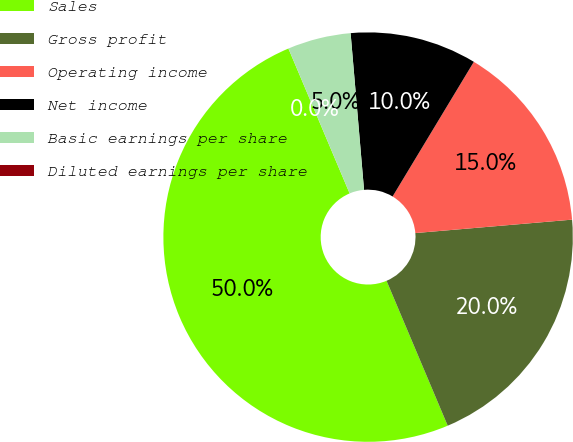<chart> <loc_0><loc_0><loc_500><loc_500><pie_chart><fcel>Sales<fcel>Gross profit<fcel>Operating income<fcel>Net income<fcel>Basic earnings per share<fcel>Diluted earnings per share<nl><fcel>49.99%<fcel>20.0%<fcel>15.0%<fcel>10.0%<fcel>5.0%<fcel>0.0%<nl></chart> 